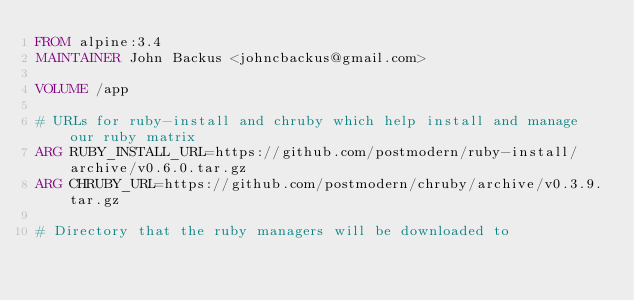<code> <loc_0><loc_0><loc_500><loc_500><_Dockerfile_>FROM alpine:3.4
MAINTAINER John Backus <johncbackus@gmail.com>

VOLUME /app

# URLs for ruby-install and chruby which help install and manage our ruby matrix
ARG RUBY_INSTALL_URL=https://github.com/postmodern/ruby-install/archive/v0.6.0.tar.gz
ARG CHRUBY_URL=https://github.com/postmodern/chruby/archive/v0.3.9.tar.gz

# Directory that the ruby managers will be downloaded to</code> 